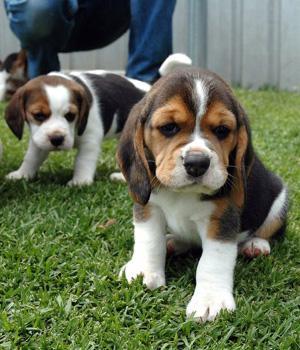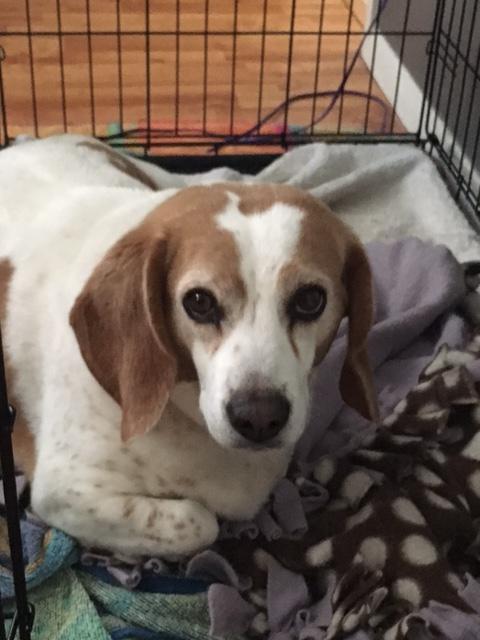The first image is the image on the left, the second image is the image on the right. For the images displayed, is the sentence "There are no more than two dogs." factually correct? Answer yes or no. No. The first image is the image on the left, the second image is the image on the right. Considering the images on both sides, is "An image includes two tri-color beagles of the same approximate size." valid? Answer yes or no. Yes. 